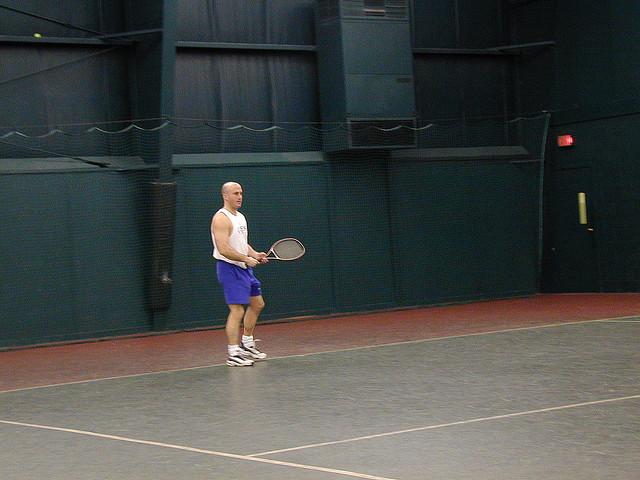Where is the man holding the racket with both hands?
Quick response, please. Tennis court. Is this a doubles match?
Quick response, please. No. What sport is being played here?
Write a very short answer. Tennis. Is this man athletic?
Concise answer only. Yes. Is the man trying to grab the tennis ball?
Write a very short answer. No. Is this man in a stance prepared to hit a ball?
Short answer required. Yes. 